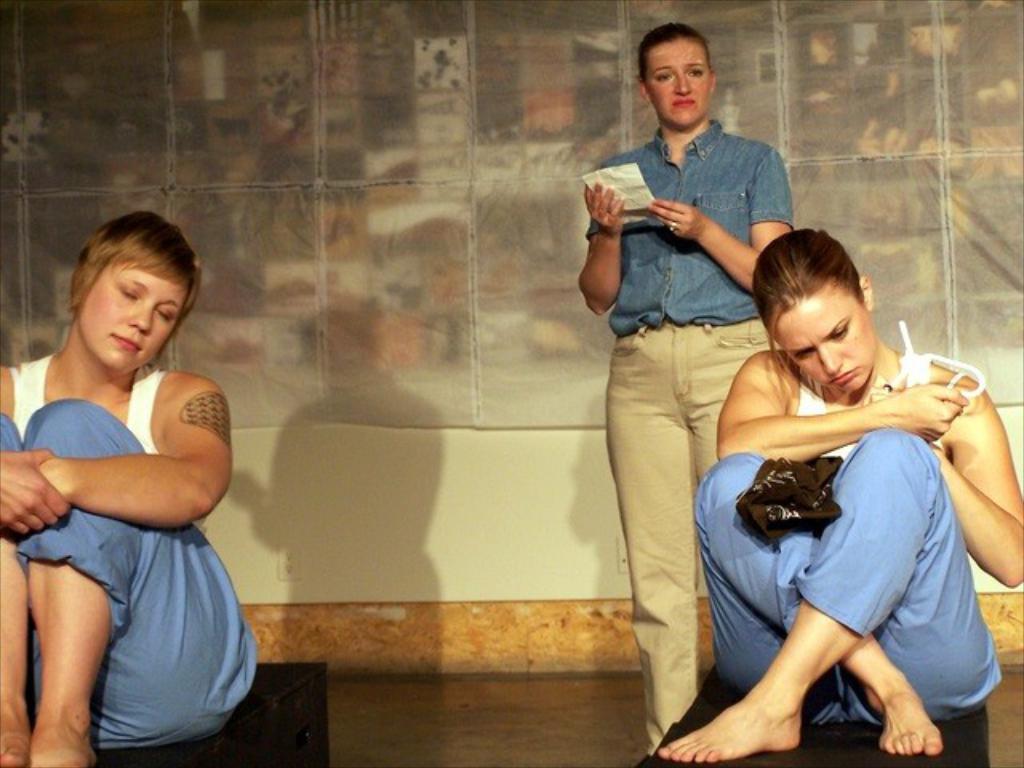Describe this image in one or two sentences. In this picture I can see two persons sitting, there is a person standing, and in the background there is a cloth and a wall. 